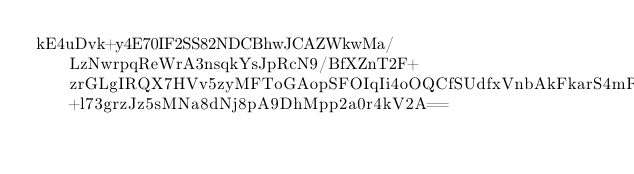Convert code to text. <code><loc_0><loc_0><loc_500><loc_500><_SML_>kE4uDvk+y4E70IF2SS82NDCBhwJCAZWkwMa/LzNwrpqReWrA3nsqkYsJpRcN9/BfXZnT2F+zrGLgIRQX7HVv5zyMFToGAopSFOIqIi4oOQCfSUdfxVnbAkFkarS4mRe3q3uRAFhkzI4hYTflrFV6jiI2YSpOncL4QouIa8SH2s+l73grzJz5sMNa8dNj8pA9DhMpp2a0r4kV2A==</code> 